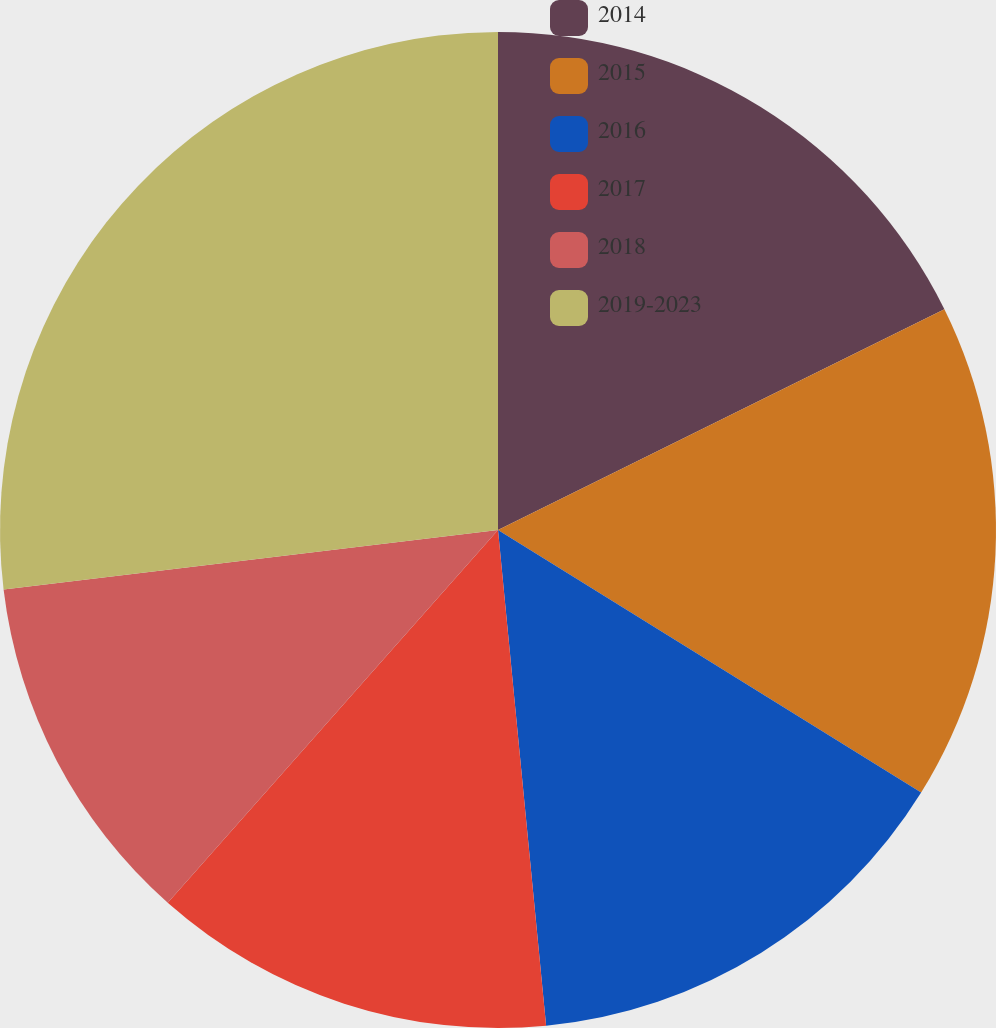<chart> <loc_0><loc_0><loc_500><loc_500><pie_chart><fcel>2014<fcel>2015<fcel>2016<fcel>2017<fcel>2018<fcel>2019-2023<nl><fcel>17.69%<fcel>16.15%<fcel>14.62%<fcel>13.08%<fcel>11.55%<fcel>26.91%<nl></chart> 